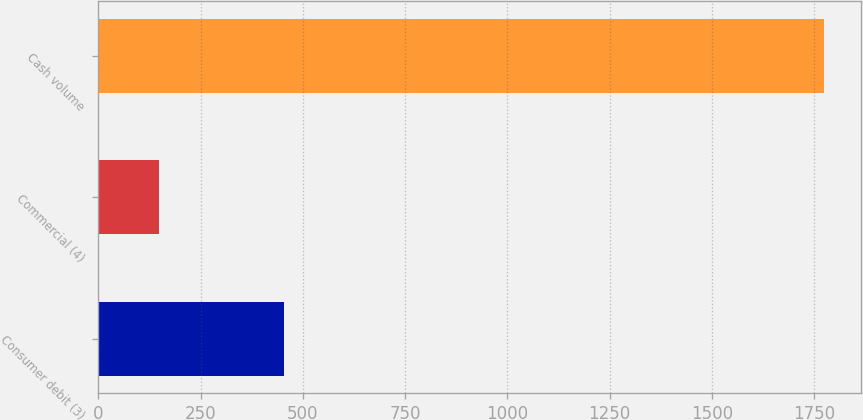<chart> <loc_0><loc_0><loc_500><loc_500><bar_chart><fcel>Consumer debit (3)<fcel>Commercial (4)<fcel>Cash volume<nl><fcel>454<fcel>148<fcel>1775<nl></chart> 